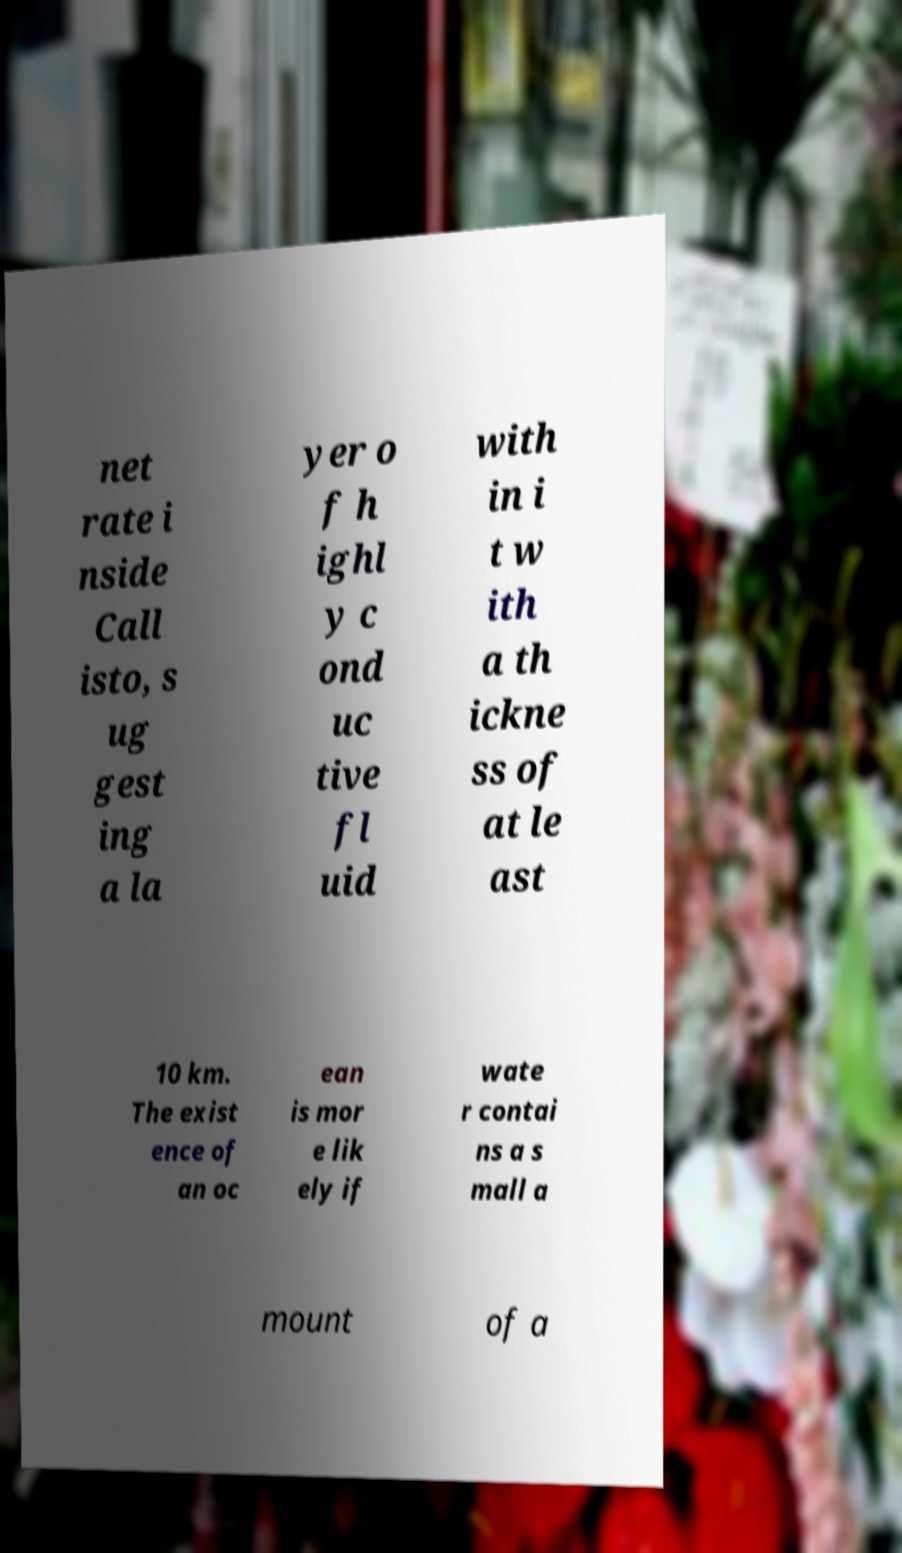Could you extract and type out the text from this image? net rate i nside Call isto, s ug gest ing a la yer o f h ighl y c ond uc tive fl uid with in i t w ith a th ickne ss of at le ast 10 km. The exist ence of an oc ean is mor e lik ely if wate r contai ns a s mall a mount of a 